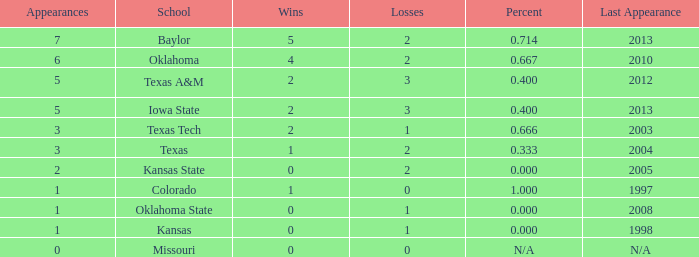How many educational institutions had a victory-defeat ratio of 1.0. 